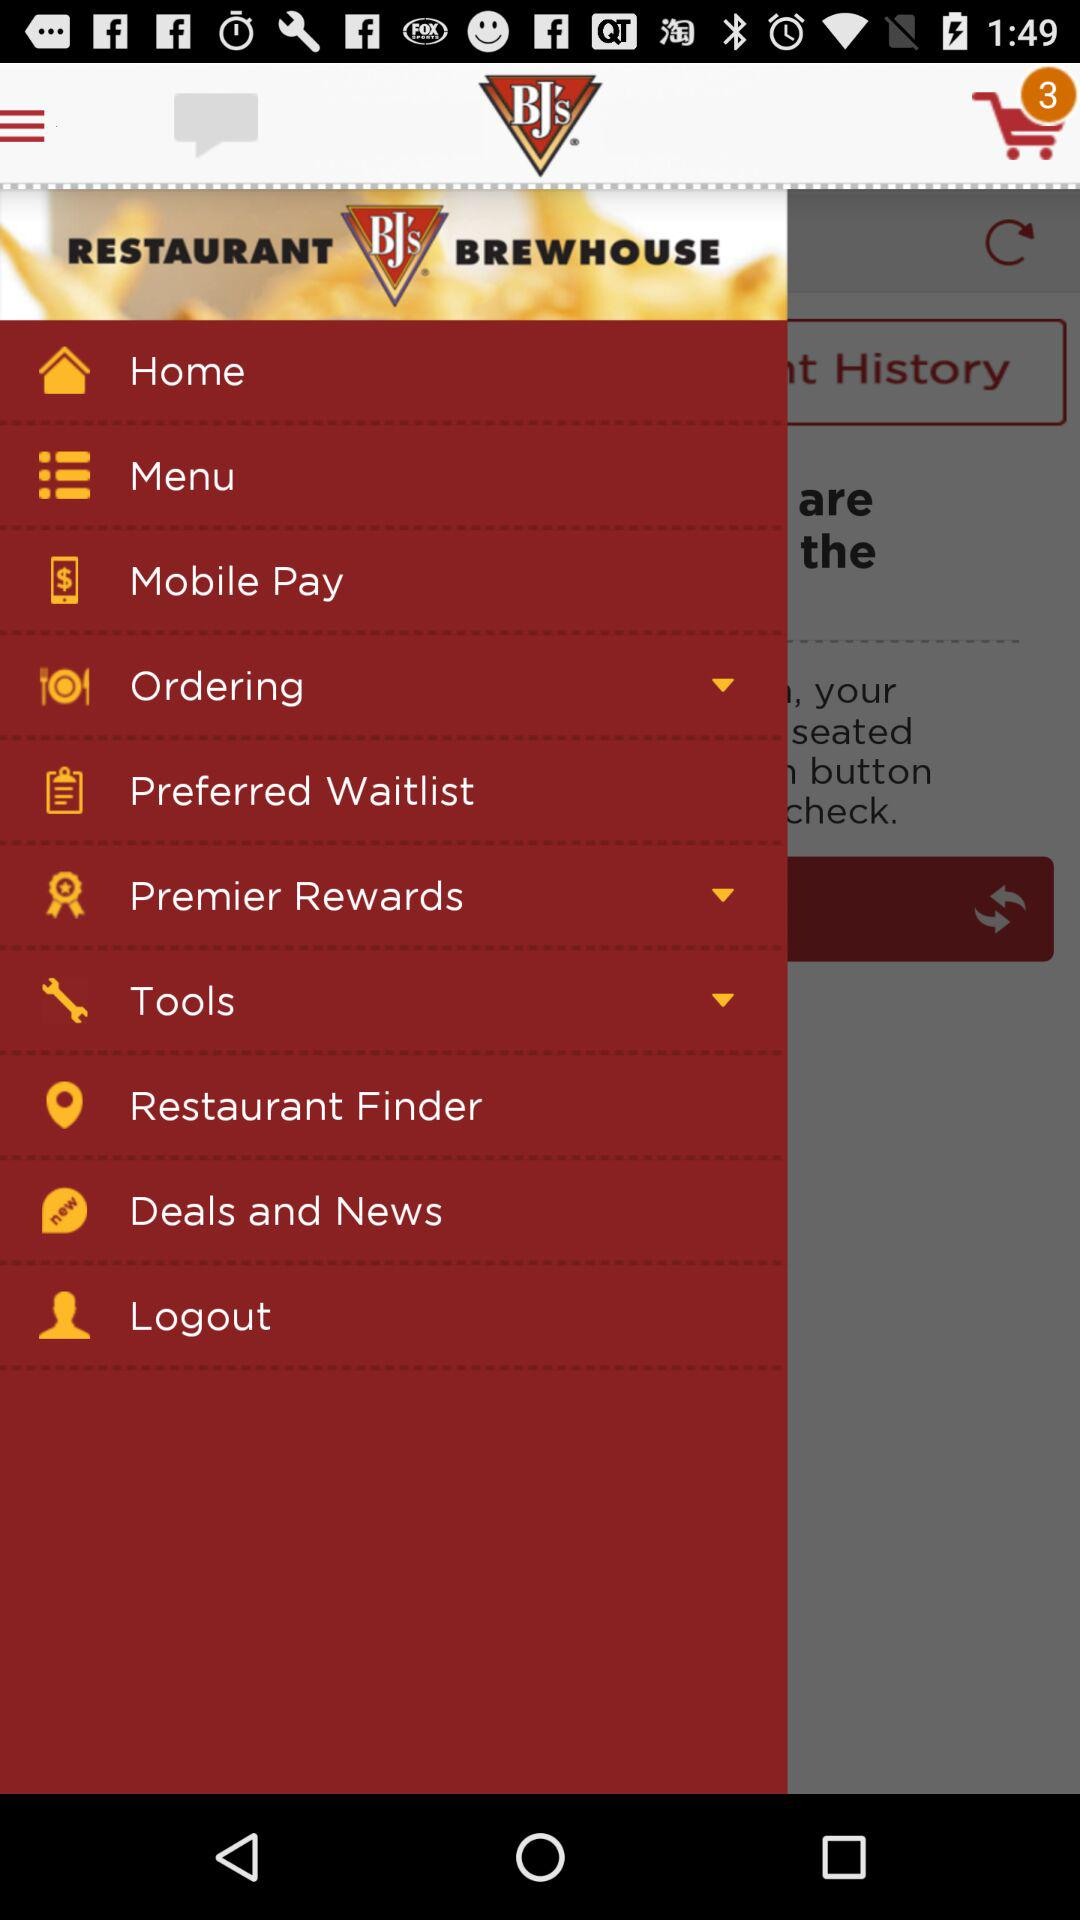What is the app name? The app name is "BJ's". 